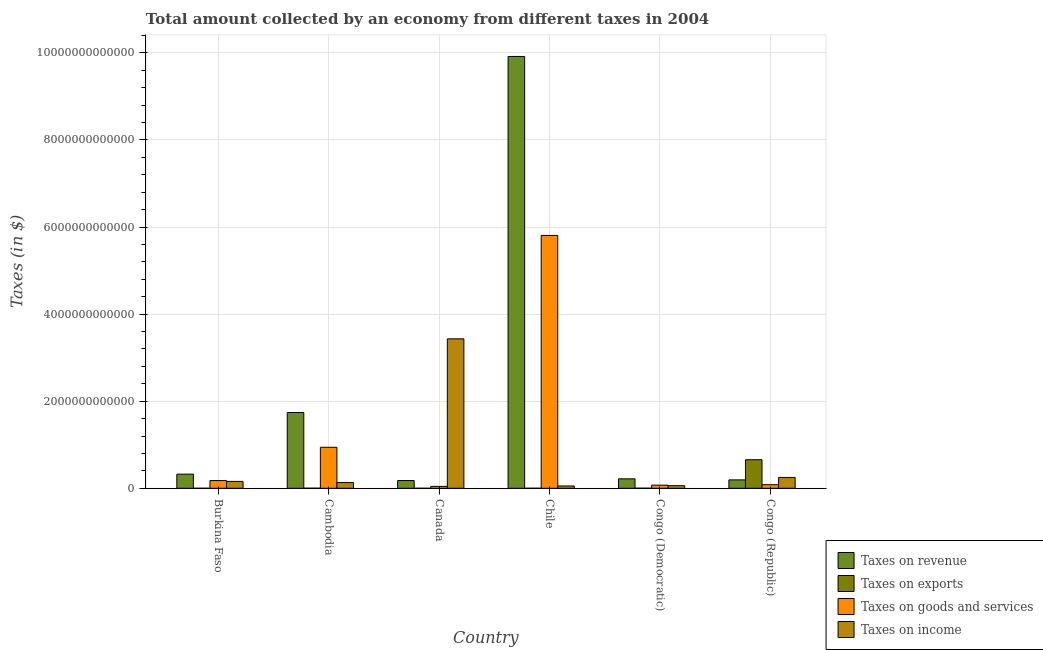How many groups of bars are there?
Your answer should be compact. 6. Are the number of bars on each tick of the X-axis equal?
Make the answer very short. Yes. How many bars are there on the 2nd tick from the left?
Make the answer very short. 4. What is the label of the 3rd group of bars from the left?
Your answer should be compact. Canada. What is the amount collected as tax on income in Chile?
Your answer should be very brief. 5.31e+1. Across all countries, what is the maximum amount collected as tax on income?
Make the answer very short. 3.43e+12. Across all countries, what is the minimum amount collected as tax on revenue?
Make the answer very short. 1.78e+11. In which country was the amount collected as tax on income minimum?
Ensure brevity in your answer.  Chile. What is the total amount collected as tax on exports in the graph?
Your answer should be very brief. 6.59e+11. What is the difference between the amount collected as tax on income in Chile and that in Congo (Democratic)?
Ensure brevity in your answer.  -6.23e+09. What is the difference between the amount collected as tax on exports in Cambodia and the amount collected as tax on goods in Burkina Faso?
Your response must be concise. -1.76e+11. What is the average amount collected as tax on exports per country?
Make the answer very short. 1.10e+11. What is the difference between the amount collected as tax on exports and amount collected as tax on revenue in Cambodia?
Give a very brief answer. -1.74e+12. In how many countries, is the amount collected as tax on goods greater than 1600000000000 $?
Keep it short and to the point. 1. What is the ratio of the amount collected as tax on goods in Canada to that in Congo (Republic)?
Provide a succinct answer. 0.53. Is the amount collected as tax on goods in Burkina Faso less than that in Canada?
Ensure brevity in your answer.  No. Is the difference between the amount collected as tax on revenue in Cambodia and Canada greater than the difference between the amount collected as tax on goods in Cambodia and Canada?
Ensure brevity in your answer.  Yes. What is the difference between the highest and the second highest amount collected as tax on revenue?
Provide a succinct answer. 8.18e+12. What is the difference between the highest and the lowest amount collected as tax on income?
Keep it short and to the point. 3.38e+12. Is the sum of the amount collected as tax on goods in Burkina Faso and Canada greater than the maximum amount collected as tax on exports across all countries?
Ensure brevity in your answer.  No. What does the 3rd bar from the left in Canada represents?
Your answer should be very brief. Taxes on goods and services. What does the 2nd bar from the right in Canada represents?
Your answer should be very brief. Taxes on goods and services. Is it the case that in every country, the sum of the amount collected as tax on revenue and amount collected as tax on exports is greater than the amount collected as tax on goods?
Your answer should be very brief. Yes. Are all the bars in the graph horizontal?
Offer a terse response. No. What is the difference between two consecutive major ticks on the Y-axis?
Give a very brief answer. 2.00e+12. Where does the legend appear in the graph?
Offer a terse response. Bottom right. How are the legend labels stacked?
Keep it short and to the point. Vertical. What is the title of the graph?
Make the answer very short. Total amount collected by an economy from different taxes in 2004. Does "Greece" appear as one of the legend labels in the graph?
Your answer should be compact. No. What is the label or title of the Y-axis?
Provide a succinct answer. Taxes (in $). What is the Taxes (in $) in Taxes on revenue in Burkina Faso?
Ensure brevity in your answer.  3.25e+11. What is the Taxes (in $) in Taxes on exports in Burkina Faso?
Make the answer very short. 1.08e+07. What is the Taxes (in $) in Taxes on goods and services in Burkina Faso?
Your answer should be compact. 1.77e+11. What is the Taxes (in $) in Taxes on income in Burkina Faso?
Provide a succinct answer. 1.58e+11. What is the Taxes (in $) of Taxes on revenue in Cambodia?
Offer a very short reply. 1.74e+12. What is the Taxes (in $) in Taxes on exports in Cambodia?
Your response must be concise. 1.60e+09. What is the Taxes (in $) of Taxes on goods and services in Cambodia?
Keep it short and to the point. 9.42e+11. What is the Taxes (in $) of Taxes on income in Cambodia?
Provide a succinct answer. 1.31e+11. What is the Taxes (in $) in Taxes on revenue in Canada?
Offer a terse response. 1.78e+11. What is the Taxes (in $) in Taxes on exports in Canada?
Ensure brevity in your answer.  4.41e+06. What is the Taxes (in $) in Taxes on goods and services in Canada?
Offer a terse response. 4.36e+1. What is the Taxes (in $) in Taxes on income in Canada?
Offer a terse response. 3.43e+12. What is the Taxes (in $) in Taxes on revenue in Chile?
Give a very brief answer. 9.92e+12. What is the Taxes (in $) of Taxes on exports in Chile?
Ensure brevity in your answer.  5.27e+08. What is the Taxes (in $) in Taxes on goods and services in Chile?
Offer a terse response. 5.81e+12. What is the Taxes (in $) of Taxes on income in Chile?
Give a very brief answer. 5.31e+1. What is the Taxes (in $) of Taxes on revenue in Congo (Democratic)?
Provide a succinct answer. 2.17e+11. What is the Taxes (in $) of Taxes on exports in Congo (Democratic)?
Your answer should be compact. 1.62e+09. What is the Taxes (in $) of Taxes on goods and services in Congo (Democratic)?
Ensure brevity in your answer.  7.21e+1. What is the Taxes (in $) in Taxes on income in Congo (Democratic)?
Your response must be concise. 5.93e+1. What is the Taxes (in $) in Taxes on revenue in Congo (Republic)?
Your answer should be very brief. 1.93e+11. What is the Taxes (in $) in Taxes on exports in Congo (Republic)?
Provide a succinct answer. 6.56e+11. What is the Taxes (in $) of Taxes on goods and services in Congo (Republic)?
Provide a short and direct response. 8.21e+1. What is the Taxes (in $) of Taxes on income in Congo (Republic)?
Keep it short and to the point. 2.49e+11. Across all countries, what is the maximum Taxes (in $) of Taxes on revenue?
Your answer should be compact. 9.92e+12. Across all countries, what is the maximum Taxes (in $) of Taxes on exports?
Provide a succinct answer. 6.56e+11. Across all countries, what is the maximum Taxes (in $) in Taxes on goods and services?
Give a very brief answer. 5.81e+12. Across all countries, what is the maximum Taxes (in $) of Taxes on income?
Make the answer very short. 3.43e+12. Across all countries, what is the minimum Taxes (in $) of Taxes on revenue?
Provide a succinct answer. 1.78e+11. Across all countries, what is the minimum Taxes (in $) in Taxes on exports?
Offer a terse response. 4.41e+06. Across all countries, what is the minimum Taxes (in $) of Taxes on goods and services?
Your answer should be compact. 4.36e+1. Across all countries, what is the minimum Taxes (in $) in Taxes on income?
Offer a very short reply. 5.31e+1. What is the total Taxes (in $) in Taxes on revenue in the graph?
Provide a succinct answer. 1.26e+13. What is the total Taxes (in $) in Taxes on exports in the graph?
Provide a succinct answer. 6.59e+11. What is the total Taxes (in $) of Taxes on goods and services in the graph?
Offer a very short reply. 7.12e+12. What is the total Taxes (in $) in Taxes on income in the graph?
Provide a succinct answer. 4.08e+12. What is the difference between the Taxes (in $) of Taxes on revenue in Burkina Faso and that in Cambodia?
Provide a short and direct response. -1.42e+12. What is the difference between the Taxes (in $) of Taxes on exports in Burkina Faso and that in Cambodia?
Your response must be concise. -1.59e+09. What is the difference between the Taxes (in $) of Taxes on goods and services in Burkina Faso and that in Cambodia?
Your response must be concise. -7.65e+11. What is the difference between the Taxes (in $) of Taxes on income in Burkina Faso and that in Cambodia?
Provide a short and direct response. 2.66e+1. What is the difference between the Taxes (in $) in Taxes on revenue in Burkina Faso and that in Canada?
Your response must be concise. 1.47e+11. What is the difference between the Taxes (in $) in Taxes on exports in Burkina Faso and that in Canada?
Keep it short and to the point. 6.44e+06. What is the difference between the Taxes (in $) in Taxes on goods and services in Burkina Faso and that in Canada?
Provide a short and direct response. 1.34e+11. What is the difference between the Taxes (in $) of Taxes on income in Burkina Faso and that in Canada?
Give a very brief answer. -3.27e+12. What is the difference between the Taxes (in $) in Taxes on revenue in Burkina Faso and that in Chile?
Offer a terse response. -9.59e+12. What is the difference between the Taxes (in $) in Taxes on exports in Burkina Faso and that in Chile?
Provide a succinct answer. -5.16e+08. What is the difference between the Taxes (in $) in Taxes on goods and services in Burkina Faso and that in Chile?
Your answer should be very brief. -5.63e+12. What is the difference between the Taxes (in $) in Taxes on income in Burkina Faso and that in Chile?
Your response must be concise. 1.05e+11. What is the difference between the Taxes (in $) of Taxes on revenue in Burkina Faso and that in Congo (Democratic)?
Ensure brevity in your answer.  1.08e+11. What is the difference between the Taxes (in $) of Taxes on exports in Burkina Faso and that in Congo (Democratic)?
Your answer should be compact. -1.60e+09. What is the difference between the Taxes (in $) in Taxes on goods and services in Burkina Faso and that in Congo (Democratic)?
Give a very brief answer. 1.05e+11. What is the difference between the Taxes (in $) in Taxes on income in Burkina Faso and that in Congo (Democratic)?
Give a very brief answer. 9.86e+1. What is the difference between the Taxes (in $) in Taxes on revenue in Burkina Faso and that in Congo (Republic)?
Provide a succinct answer. 1.32e+11. What is the difference between the Taxes (in $) in Taxes on exports in Burkina Faso and that in Congo (Republic)?
Your answer should be compact. -6.56e+11. What is the difference between the Taxes (in $) in Taxes on goods and services in Burkina Faso and that in Congo (Republic)?
Provide a short and direct response. 9.52e+1. What is the difference between the Taxes (in $) of Taxes on income in Burkina Faso and that in Congo (Republic)?
Keep it short and to the point. -9.11e+1. What is the difference between the Taxes (in $) in Taxes on revenue in Cambodia and that in Canada?
Give a very brief answer. 1.56e+12. What is the difference between the Taxes (in $) in Taxes on exports in Cambodia and that in Canada?
Offer a very short reply. 1.60e+09. What is the difference between the Taxes (in $) of Taxes on goods and services in Cambodia and that in Canada?
Give a very brief answer. 8.98e+11. What is the difference between the Taxes (in $) of Taxes on income in Cambodia and that in Canada?
Offer a very short reply. -3.30e+12. What is the difference between the Taxes (in $) of Taxes on revenue in Cambodia and that in Chile?
Provide a succinct answer. -8.18e+12. What is the difference between the Taxes (in $) in Taxes on exports in Cambodia and that in Chile?
Your answer should be very brief. 1.07e+09. What is the difference between the Taxes (in $) of Taxes on goods and services in Cambodia and that in Chile?
Offer a very short reply. -4.87e+12. What is the difference between the Taxes (in $) in Taxes on income in Cambodia and that in Chile?
Your response must be concise. 7.83e+1. What is the difference between the Taxes (in $) in Taxes on revenue in Cambodia and that in Congo (Democratic)?
Give a very brief answer. 1.52e+12. What is the difference between the Taxes (in $) in Taxes on exports in Cambodia and that in Congo (Democratic)?
Provide a succinct answer. -1.54e+07. What is the difference between the Taxes (in $) of Taxes on goods and services in Cambodia and that in Congo (Democratic)?
Your answer should be compact. 8.70e+11. What is the difference between the Taxes (in $) in Taxes on income in Cambodia and that in Congo (Democratic)?
Your response must be concise. 7.20e+1. What is the difference between the Taxes (in $) in Taxes on revenue in Cambodia and that in Congo (Republic)?
Your response must be concise. 1.55e+12. What is the difference between the Taxes (in $) of Taxes on exports in Cambodia and that in Congo (Republic)?
Offer a very short reply. -6.54e+11. What is the difference between the Taxes (in $) of Taxes on goods and services in Cambodia and that in Congo (Republic)?
Give a very brief answer. 8.60e+11. What is the difference between the Taxes (in $) in Taxes on income in Cambodia and that in Congo (Republic)?
Your answer should be very brief. -1.18e+11. What is the difference between the Taxes (in $) of Taxes on revenue in Canada and that in Chile?
Offer a terse response. -9.74e+12. What is the difference between the Taxes (in $) of Taxes on exports in Canada and that in Chile?
Make the answer very short. -5.23e+08. What is the difference between the Taxes (in $) of Taxes on goods and services in Canada and that in Chile?
Keep it short and to the point. -5.76e+12. What is the difference between the Taxes (in $) of Taxes on income in Canada and that in Chile?
Ensure brevity in your answer.  3.38e+12. What is the difference between the Taxes (in $) in Taxes on revenue in Canada and that in Congo (Democratic)?
Your answer should be very brief. -3.92e+1. What is the difference between the Taxes (in $) in Taxes on exports in Canada and that in Congo (Democratic)?
Keep it short and to the point. -1.61e+09. What is the difference between the Taxes (in $) of Taxes on goods and services in Canada and that in Congo (Democratic)?
Your answer should be compact. -2.85e+1. What is the difference between the Taxes (in $) in Taxes on income in Canada and that in Congo (Democratic)?
Your answer should be very brief. 3.37e+12. What is the difference between the Taxes (in $) of Taxes on revenue in Canada and that in Congo (Republic)?
Provide a short and direct response. -1.49e+1. What is the difference between the Taxes (in $) in Taxes on exports in Canada and that in Congo (Republic)?
Offer a terse response. -6.56e+11. What is the difference between the Taxes (in $) of Taxes on goods and services in Canada and that in Congo (Republic)?
Your answer should be very brief. -3.84e+1. What is the difference between the Taxes (in $) of Taxes on income in Canada and that in Congo (Republic)?
Your answer should be compact. 3.18e+12. What is the difference between the Taxes (in $) in Taxes on revenue in Chile and that in Congo (Democratic)?
Offer a terse response. 9.70e+12. What is the difference between the Taxes (in $) in Taxes on exports in Chile and that in Congo (Democratic)?
Provide a short and direct response. -1.09e+09. What is the difference between the Taxes (in $) of Taxes on goods and services in Chile and that in Congo (Democratic)?
Your response must be concise. 5.74e+12. What is the difference between the Taxes (in $) of Taxes on income in Chile and that in Congo (Democratic)?
Your answer should be very brief. -6.23e+09. What is the difference between the Taxes (in $) in Taxes on revenue in Chile and that in Congo (Republic)?
Your answer should be very brief. 9.73e+12. What is the difference between the Taxes (in $) of Taxes on exports in Chile and that in Congo (Republic)?
Your response must be concise. -6.55e+11. What is the difference between the Taxes (in $) in Taxes on goods and services in Chile and that in Congo (Republic)?
Keep it short and to the point. 5.73e+12. What is the difference between the Taxes (in $) of Taxes on income in Chile and that in Congo (Republic)?
Offer a terse response. -1.96e+11. What is the difference between the Taxes (in $) of Taxes on revenue in Congo (Democratic) and that in Congo (Republic)?
Provide a succinct answer. 2.43e+1. What is the difference between the Taxes (in $) of Taxes on exports in Congo (Democratic) and that in Congo (Republic)?
Your answer should be very brief. -6.54e+11. What is the difference between the Taxes (in $) in Taxes on goods and services in Congo (Democratic) and that in Congo (Republic)?
Make the answer very short. -9.97e+09. What is the difference between the Taxes (in $) in Taxes on income in Congo (Democratic) and that in Congo (Republic)?
Make the answer very short. -1.90e+11. What is the difference between the Taxes (in $) of Taxes on revenue in Burkina Faso and the Taxes (in $) of Taxes on exports in Cambodia?
Your response must be concise. 3.23e+11. What is the difference between the Taxes (in $) of Taxes on revenue in Burkina Faso and the Taxes (in $) of Taxes on goods and services in Cambodia?
Offer a terse response. -6.17e+11. What is the difference between the Taxes (in $) in Taxes on revenue in Burkina Faso and the Taxes (in $) in Taxes on income in Cambodia?
Offer a terse response. 1.93e+11. What is the difference between the Taxes (in $) of Taxes on exports in Burkina Faso and the Taxes (in $) of Taxes on goods and services in Cambodia?
Provide a succinct answer. -9.42e+11. What is the difference between the Taxes (in $) of Taxes on exports in Burkina Faso and the Taxes (in $) of Taxes on income in Cambodia?
Give a very brief answer. -1.31e+11. What is the difference between the Taxes (in $) in Taxes on goods and services in Burkina Faso and the Taxes (in $) in Taxes on income in Cambodia?
Make the answer very short. 4.59e+1. What is the difference between the Taxes (in $) in Taxes on revenue in Burkina Faso and the Taxes (in $) in Taxes on exports in Canada?
Offer a very short reply. 3.25e+11. What is the difference between the Taxes (in $) in Taxes on revenue in Burkina Faso and the Taxes (in $) in Taxes on goods and services in Canada?
Your answer should be compact. 2.81e+11. What is the difference between the Taxes (in $) in Taxes on revenue in Burkina Faso and the Taxes (in $) in Taxes on income in Canada?
Offer a very short reply. -3.11e+12. What is the difference between the Taxes (in $) of Taxes on exports in Burkina Faso and the Taxes (in $) of Taxes on goods and services in Canada?
Offer a terse response. -4.36e+1. What is the difference between the Taxes (in $) in Taxes on exports in Burkina Faso and the Taxes (in $) in Taxes on income in Canada?
Ensure brevity in your answer.  -3.43e+12. What is the difference between the Taxes (in $) in Taxes on goods and services in Burkina Faso and the Taxes (in $) in Taxes on income in Canada?
Give a very brief answer. -3.26e+12. What is the difference between the Taxes (in $) in Taxes on revenue in Burkina Faso and the Taxes (in $) in Taxes on exports in Chile?
Your response must be concise. 3.24e+11. What is the difference between the Taxes (in $) in Taxes on revenue in Burkina Faso and the Taxes (in $) in Taxes on goods and services in Chile?
Make the answer very short. -5.48e+12. What is the difference between the Taxes (in $) of Taxes on revenue in Burkina Faso and the Taxes (in $) of Taxes on income in Chile?
Your answer should be very brief. 2.72e+11. What is the difference between the Taxes (in $) in Taxes on exports in Burkina Faso and the Taxes (in $) in Taxes on goods and services in Chile?
Make the answer very short. -5.81e+12. What is the difference between the Taxes (in $) of Taxes on exports in Burkina Faso and the Taxes (in $) of Taxes on income in Chile?
Offer a very short reply. -5.31e+1. What is the difference between the Taxes (in $) in Taxes on goods and services in Burkina Faso and the Taxes (in $) in Taxes on income in Chile?
Offer a terse response. 1.24e+11. What is the difference between the Taxes (in $) in Taxes on revenue in Burkina Faso and the Taxes (in $) in Taxes on exports in Congo (Democratic)?
Ensure brevity in your answer.  3.23e+11. What is the difference between the Taxes (in $) of Taxes on revenue in Burkina Faso and the Taxes (in $) of Taxes on goods and services in Congo (Democratic)?
Offer a very short reply. 2.53e+11. What is the difference between the Taxes (in $) in Taxes on revenue in Burkina Faso and the Taxes (in $) in Taxes on income in Congo (Democratic)?
Keep it short and to the point. 2.65e+11. What is the difference between the Taxes (in $) of Taxes on exports in Burkina Faso and the Taxes (in $) of Taxes on goods and services in Congo (Democratic)?
Keep it short and to the point. -7.21e+1. What is the difference between the Taxes (in $) of Taxes on exports in Burkina Faso and the Taxes (in $) of Taxes on income in Congo (Democratic)?
Your answer should be very brief. -5.93e+1. What is the difference between the Taxes (in $) of Taxes on goods and services in Burkina Faso and the Taxes (in $) of Taxes on income in Congo (Democratic)?
Your answer should be very brief. 1.18e+11. What is the difference between the Taxes (in $) in Taxes on revenue in Burkina Faso and the Taxes (in $) in Taxes on exports in Congo (Republic)?
Your answer should be very brief. -3.31e+11. What is the difference between the Taxes (in $) of Taxes on revenue in Burkina Faso and the Taxes (in $) of Taxes on goods and services in Congo (Republic)?
Ensure brevity in your answer.  2.43e+11. What is the difference between the Taxes (in $) in Taxes on revenue in Burkina Faso and the Taxes (in $) in Taxes on income in Congo (Republic)?
Keep it short and to the point. 7.56e+1. What is the difference between the Taxes (in $) in Taxes on exports in Burkina Faso and the Taxes (in $) in Taxes on goods and services in Congo (Republic)?
Your answer should be compact. -8.21e+1. What is the difference between the Taxes (in $) in Taxes on exports in Burkina Faso and the Taxes (in $) in Taxes on income in Congo (Republic)?
Your answer should be very brief. -2.49e+11. What is the difference between the Taxes (in $) in Taxes on goods and services in Burkina Faso and the Taxes (in $) in Taxes on income in Congo (Republic)?
Offer a terse response. -7.17e+1. What is the difference between the Taxes (in $) of Taxes on revenue in Cambodia and the Taxes (in $) of Taxes on exports in Canada?
Give a very brief answer. 1.74e+12. What is the difference between the Taxes (in $) of Taxes on revenue in Cambodia and the Taxes (in $) of Taxes on goods and services in Canada?
Your response must be concise. 1.70e+12. What is the difference between the Taxes (in $) in Taxes on revenue in Cambodia and the Taxes (in $) in Taxes on income in Canada?
Provide a short and direct response. -1.69e+12. What is the difference between the Taxes (in $) in Taxes on exports in Cambodia and the Taxes (in $) in Taxes on goods and services in Canada?
Give a very brief answer. -4.20e+1. What is the difference between the Taxes (in $) of Taxes on exports in Cambodia and the Taxes (in $) of Taxes on income in Canada?
Provide a short and direct response. -3.43e+12. What is the difference between the Taxes (in $) of Taxes on goods and services in Cambodia and the Taxes (in $) of Taxes on income in Canada?
Give a very brief answer. -2.49e+12. What is the difference between the Taxes (in $) of Taxes on revenue in Cambodia and the Taxes (in $) of Taxes on exports in Chile?
Offer a very short reply. 1.74e+12. What is the difference between the Taxes (in $) of Taxes on revenue in Cambodia and the Taxes (in $) of Taxes on goods and services in Chile?
Ensure brevity in your answer.  -4.07e+12. What is the difference between the Taxes (in $) in Taxes on revenue in Cambodia and the Taxes (in $) in Taxes on income in Chile?
Provide a succinct answer. 1.69e+12. What is the difference between the Taxes (in $) of Taxes on exports in Cambodia and the Taxes (in $) of Taxes on goods and services in Chile?
Provide a succinct answer. -5.81e+12. What is the difference between the Taxes (in $) in Taxes on exports in Cambodia and the Taxes (in $) in Taxes on income in Chile?
Your answer should be compact. -5.15e+1. What is the difference between the Taxes (in $) of Taxes on goods and services in Cambodia and the Taxes (in $) of Taxes on income in Chile?
Offer a terse response. 8.89e+11. What is the difference between the Taxes (in $) of Taxes on revenue in Cambodia and the Taxes (in $) of Taxes on exports in Congo (Democratic)?
Your answer should be compact. 1.74e+12. What is the difference between the Taxes (in $) in Taxes on revenue in Cambodia and the Taxes (in $) in Taxes on goods and services in Congo (Democratic)?
Give a very brief answer. 1.67e+12. What is the difference between the Taxes (in $) in Taxes on revenue in Cambodia and the Taxes (in $) in Taxes on income in Congo (Democratic)?
Your answer should be very brief. 1.68e+12. What is the difference between the Taxes (in $) of Taxes on exports in Cambodia and the Taxes (in $) of Taxes on goods and services in Congo (Democratic)?
Keep it short and to the point. -7.05e+1. What is the difference between the Taxes (in $) in Taxes on exports in Cambodia and the Taxes (in $) in Taxes on income in Congo (Democratic)?
Your response must be concise. -5.77e+1. What is the difference between the Taxes (in $) of Taxes on goods and services in Cambodia and the Taxes (in $) of Taxes on income in Congo (Democratic)?
Provide a succinct answer. 8.82e+11. What is the difference between the Taxes (in $) of Taxes on revenue in Cambodia and the Taxes (in $) of Taxes on exports in Congo (Republic)?
Offer a very short reply. 1.08e+12. What is the difference between the Taxes (in $) in Taxes on revenue in Cambodia and the Taxes (in $) in Taxes on goods and services in Congo (Republic)?
Keep it short and to the point. 1.66e+12. What is the difference between the Taxes (in $) of Taxes on revenue in Cambodia and the Taxes (in $) of Taxes on income in Congo (Republic)?
Your response must be concise. 1.49e+12. What is the difference between the Taxes (in $) of Taxes on exports in Cambodia and the Taxes (in $) of Taxes on goods and services in Congo (Republic)?
Ensure brevity in your answer.  -8.05e+1. What is the difference between the Taxes (in $) of Taxes on exports in Cambodia and the Taxes (in $) of Taxes on income in Congo (Republic)?
Your answer should be compact. -2.47e+11. What is the difference between the Taxes (in $) of Taxes on goods and services in Cambodia and the Taxes (in $) of Taxes on income in Congo (Republic)?
Ensure brevity in your answer.  6.93e+11. What is the difference between the Taxes (in $) in Taxes on revenue in Canada and the Taxes (in $) in Taxes on exports in Chile?
Offer a very short reply. 1.77e+11. What is the difference between the Taxes (in $) of Taxes on revenue in Canada and the Taxes (in $) of Taxes on goods and services in Chile?
Make the answer very short. -5.63e+12. What is the difference between the Taxes (in $) in Taxes on revenue in Canada and the Taxes (in $) in Taxes on income in Chile?
Your response must be concise. 1.25e+11. What is the difference between the Taxes (in $) of Taxes on exports in Canada and the Taxes (in $) of Taxes on goods and services in Chile?
Give a very brief answer. -5.81e+12. What is the difference between the Taxes (in $) of Taxes on exports in Canada and the Taxes (in $) of Taxes on income in Chile?
Ensure brevity in your answer.  -5.31e+1. What is the difference between the Taxes (in $) of Taxes on goods and services in Canada and the Taxes (in $) of Taxes on income in Chile?
Provide a succinct answer. -9.45e+09. What is the difference between the Taxes (in $) in Taxes on revenue in Canada and the Taxes (in $) in Taxes on exports in Congo (Democratic)?
Give a very brief answer. 1.76e+11. What is the difference between the Taxes (in $) in Taxes on revenue in Canada and the Taxes (in $) in Taxes on goods and services in Congo (Democratic)?
Your answer should be compact. 1.06e+11. What is the difference between the Taxes (in $) in Taxes on revenue in Canada and the Taxes (in $) in Taxes on income in Congo (Democratic)?
Keep it short and to the point. 1.19e+11. What is the difference between the Taxes (in $) in Taxes on exports in Canada and the Taxes (in $) in Taxes on goods and services in Congo (Democratic)?
Your answer should be compact. -7.21e+1. What is the difference between the Taxes (in $) of Taxes on exports in Canada and the Taxes (in $) of Taxes on income in Congo (Democratic)?
Provide a succinct answer. -5.93e+1. What is the difference between the Taxes (in $) of Taxes on goods and services in Canada and the Taxes (in $) of Taxes on income in Congo (Democratic)?
Ensure brevity in your answer.  -1.57e+1. What is the difference between the Taxes (in $) in Taxes on revenue in Canada and the Taxes (in $) in Taxes on exports in Congo (Republic)?
Your answer should be compact. -4.78e+11. What is the difference between the Taxes (in $) of Taxes on revenue in Canada and the Taxes (in $) of Taxes on goods and services in Congo (Republic)?
Ensure brevity in your answer.  9.58e+1. What is the difference between the Taxes (in $) in Taxes on revenue in Canada and the Taxes (in $) in Taxes on income in Congo (Republic)?
Provide a short and direct response. -7.11e+1. What is the difference between the Taxes (in $) in Taxes on exports in Canada and the Taxes (in $) in Taxes on goods and services in Congo (Republic)?
Give a very brief answer. -8.21e+1. What is the difference between the Taxes (in $) in Taxes on exports in Canada and the Taxes (in $) in Taxes on income in Congo (Republic)?
Offer a very short reply. -2.49e+11. What is the difference between the Taxes (in $) of Taxes on goods and services in Canada and the Taxes (in $) of Taxes on income in Congo (Republic)?
Offer a terse response. -2.05e+11. What is the difference between the Taxes (in $) in Taxes on revenue in Chile and the Taxes (in $) in Taxes on exports in Congo (Democratic)?
Provide a short and direct response. 9.92e+12. What is the difference between the Taxes (in $) of Taxes on revenue in Chile and the Taxes (in $) of Taxes on goods and services in Congo (Democratic)?
Your answer should be very brief. 9.85e+12. What is the difference between the Taxes (in $) of Taxes on revenue in Chile and the Taxes (in $) of Taxes on income in Congo (Democratic)?
Provide a succinct answer. 9.86e+12. What is the difference between the Taxes (in $) of Taxes on exports in Chile and the Taxes (in $) of Taxes on goods and services in Congo (Democratic)?
Ensure brevity in your answer.  -7.16e+1. What is the difference between the Taxes (in $) in Taxes on exports in Chile and the Taxes (in $) in Taxes on income in Congo (Democratic)?
Ensure brevity in your answer.  -5.88e+1. What is the difference between the Taxes (in $) in Taxes on goods and services in Chile and the Taxes (in $) in Taxes on income in Congo (Democratic)?
Keep it short and to the point. 5.75e+12. What is the difference between the Taxes (in $) in Taxes on revenue in Chile and the Taxes (in $) in Taxes on exports in Congo (Republic)?
Your response must be concise. 9.26e+12. What is the difference between the Taxes (in $) in Taxes on revenue in Chile and the Taxes (in $) in Taxes on goods and services in Congo (Republic)?
Your answer should be very brief. 9.84e+12. What is the difference between the Taxes (in $) of Taxes on revenue in Chile and the Taxes (in $) of Taxes on income in Congo (Republic)?
Provide a short and direct response. 9.67e+12. What is the difference between the Taxes (in $) in Taxes on exports in Chile and the Taxes (in $) in Taxes on goods and services in Congo (Republic)?
Your answer should be compact. -8.15e+1. What is the difference between the Taxes (in $) of Taxes on exports in Chile and the Taxes (in $) of Taxes on income in Congo (Republic)?
Your response must be concise. -2.48e+11. What is the difference between the Taxes (in $) of Taxes on goods and services in Chile and the Taxes (in $) of Taxes on income in Congo (Republic)?
Offer a terse response. 5.56e+12. What is the difference between the Taxes (in $) in Taxes on revenue in Congo (Democratic) and the Taxes (in $) in Taxes on exports in Congo (Republic)?
Provide a short and direct response. -4.39e+11. What is the difference between the Taxes (in $) of Taxes on revenue in Congo (Democratic) and the Taxes (in $) of Taxes on goods and services in Congo (Republic)?
Provide a succinct answer. 1.35e+11. What is the difference between the Taxes (in $) of Taxes on revenue in Congo (Democratic) and the Taxes (in $) of Taxes on income in Congo (Republic)?
Provide a succinct answer. -3.19e+1. What is the difference between the Taxes (in $) of Taxes on exports in Congo (Democratic) and the Taxes (in $) of Taxes on goods and services in Congo (Republic)?
Offer a terse response. -8.05e+1. What is the difference between the Taxes (in $) in Taxes on exports in Congo (Democratic) and the Taxes (in $) in Taxes on income in Congo (Republic)?
Provide a short and direct response. -2.47e+11. What is the difference between the Taxes (in $) of Taxes on goods and services in Congo (Democratic) and the Taxes (in $) of Taxes on income in Congo (Republic)?
Give a very brief answer. -1.77e+11. What is the average Taxes (in $) of Taxes on revenue per country?
Offer a very short reply. 2.10e+12. What is the average Taxes (in $) in Taxes on exports per country?
Provide a succinct answer. 1.10e+11. What is the average Taxes (in $) in Taxes on goods and services per country?
Your answer should be very brief. 1.19e+12. What is the average Taxes (in $) in Taxes on income per country?
Your answer should be compact. 6.81e+11. What is the difference between the Taxes (in $) in Taxes on revenue and Taxes (in $) in Taxes on exports in Burkina Faso?
Keep it short and to the point. 3.25e+11. What is the difference between the Taxes (in $) of Taxes on revenue and Taxes (in $) of Taxes on goods and services in Burkina Faso?
Your answer should be compact. 1.47e+11. What is the difference between the Taxes (in $) of Taxes on revenue and Taxes (in $) of Taxes on income in Burkina Faso?
Your response must be concise. 1.67e+11. What is the difference between the Taxes (in $) in Taxes on exports and Taxes (in $) in Taxes on goods and services in Burkina Faso?
Provide a short and direct response. -1.77e+11. What is the difference between the Taxes (in $) of Taxes on exports and Taxes (in $) of Taxes on income in Burkina Faso?
Give a very brief answer. -1.58e+11. What is the difference between the Taxes (in $) of Taxes on goods and services and Taxes (in $) of Taxes on income in Burkina Faso?
Give a very brief answer. 1.93e+1. What is the difference between the Taxes (in $) of Taxes on revenue and Taxes (in $) of Taxes on exports in Cambodia?
Provide a succinct answer. 1.74e+12. What is the difference between the Taxes (in $) of Taxes on revenue and Taxes (in $) of Taxes on goods and services in Cambodia?
Give a very brief answer. 7.98e+11. What is the difference between the Taxes (in $) of Taxes on revenue and Taxes (in $) of Taxes on income in Cambodia?
Make the answer very short. 1.61e+12. What is the difference between the Taxes (in $) in Taxes on exports and Taxes (in $) in Taxes on goods and services in Cambodia?
Offer a very short reply. -9.40e+11. What is the difference between the Taxes (in $) in Taxes on exports and Taxes (in $) in Taxes on income in Cambodia?
Offer a very short reply. -1.30e+11. What is the difference between the Taxes (in $) in Taxes on goods and services and Taxes (in $) in Taxes on income in Cambodia?
Ensure brevity in your answer.  8.10e+11. What is the difference between the Taxes (in $) in Taxes on revenue and Taxes (in $) in Taxes on exports in Canada?
Your answer should be compact. 1.78e+11. What is the difference between the Taxes (in $) in Taxes on revenue and Taxes (in $) in Taxes on goods and services in Canada?
Keep it short and to the point. 1.34e+11. What is the difference between the Taxes (in $) in Taxes on revenue and Taxes (in $) in Taxes on income in Canada?
Provide a short and direct response. -3.25e+12. What is the difference between the Taxes (in $) of Taxes on exports and Taxes (in $) of Taxes on goods and services in Canada?
Your response must be concise. -4.36e+1. What is the difference between the Taxes (in $) of Taxes on exports and Taxes (in $) of Taxes on income in Canada?
Provide a succinct answer. -3.43e+12. What is the difference between the Taxes (in $) in Taxes on goods and services and Taxes (in $) in Taxes on income in Canada?
Your response must be concise. -3.39e+12. What is the difference between the Taxes (in $) in Taxes on revenue and Taxes (in $) in Taxes on exports in Chile?
Your response must be concise. 9.92e+12. What is the difference between the Taxes (in $) of Taxes on revenue and Taxes (in $) of Taxes on goods and services in Chile?
Ensure brevity in your answer.  4.11e+12. What is the difference between the Taxes (in $) of Taxes on revenue and Taxes (in $) of Taxes on income in Chile?
Offer a very short reply. 9.87e+12. What is the difference between the Taxes (in $) in Taxes on exports and Taxes (in $) in Taxes on goods and services in Chile?
Give a very brief answer. -5.81e+12. What is the difference between the Taxes (in $) of Taxes on exports and Taxes (in $) of Taxes on income in Chile?
Your response must be concise. -5.25e+1. What is the difference between the Taxes (in $) of Taxes on goods and services and Taxes (in $) of Taxes on income in Chile?
Your response must be concise. 5.75e+12. What is the difference between the Taxes (in $) of Taxes on revenue and Taxes (in $) of Taxes on exports in Congo (Democratic)?
Your response must be concise. 2.15e+11. What is the difference between the Taxes (in $) in Taxes on revenue and Taxes (in $) in Taxes on goods and services in Congo (Democratic)?
Your answer should be very brief. 1.45e+11. What is the difference between the Taxes (in $) in Taxes on revenue and Taxes (in $) in Taxes on income in Congo (Democratic)?
Your answer should be very brief. 1.58e+11. What is the difference between the Taxes (in $) in Taxes on exports and Taxes (in $) in Taxes on goods and services in Congo (Democratic)?
Your response must be concise. -7.05e+1. What is the difference between the Taxes (in $) of Taxes on exports and Taxes (in $) of Taxes on income in Congo (Democratic)?
Give a very brief answer. -5.77e+1. What is the difference between the Taxes (in $) in Taxes on goods and services and Taxes (in $) in Taxes on income in Congo (Democratic)?
Your answer should be compact. 1.28e+1. What is the difference between the Taxes (in $) in Taxes on revenue and Taxes (in $) in Taxes on exports in Congo (Republic)?
Your answer should be compact. -4.63e+11. What is the difference between the Taxes (in $) of Taxes on revenue and Taxes (in $) of Taxes on goods and services in Congo (Republic)?
Your answer should be very brief. 1.11e+11. What is the difference between the Taxes (in $) of Taxes on revenue and Taxes (in $) of Taxes on income in Congo (Republic)?
Your answer should be very brief. -5.62e+1. What is the difference between the Taxes (in $) in Taxes on exports and Taxes (in $) in Taxes on goods and services in Congo (Republic)?
Offer a terse response. 5.74e+11. What is the difference between the Taxes (in $) of Taxes on exports and Taxes (in $) of Taxes on income in Congo (Republic)?
Provide a short and direct response. 4.07e+11. What is the difference between the Taxes (in $) of Taxes on goods and services and Taxes (in $) of Taxes on income in Congo (Republic)?
Offer a terse response. -1.67e+11. What is the ratio of the Taxes (in $) in Taxes on revenue in Burkina Faso to that in Cambodia?
Offer a very short reply. 0.19. What is the ratio of the Taxes (in $) of Taxes on exports in Burkina Faso to that in Cambodia?
Give a very brief answer. 0.01. What is the ratio of the Taxes (in $) in Taxes on goods and services in Burkina Faso to that in Cambodia?
Offer a terse response. 0.19. What is the ratio of the Taxes (in $) in Taxes on income in Burkina Faso to that in Cambodia?
Offer a very short reply. 1.2. What is the ratio of the Taxes (in $) in Taxes on revenue in Burkina Faso to that in Canada?
Your response must be concise. 1.82. What is the ratio of the Taxes (in $) of Taxes on exports in Burkina Faso to that in Canada?
Your answer should be compact. 2.46. What is the ratio of the Taxes (in $) of Taxes on goods and services in Burkina Faso to that in Canada?
Offer a terse response. 4.06. What is the ratio of the Taxes (in $) of Taxes on income in Burkina Faso to that in Canada?
Offer a very short reply. 0.05. What is the ratio of the Taxes (in $) of Taxes on revenue in Burkina Faso to that in Chile?
Offer a very short reply. 0.03. What is the ratio of the Taxes (in $) of Taxes on exports in Burkina Faso to that in Chile?
Your response must be concise. 0.02. What is the ratio of the Taxes (in $) of Taxes on goods and services in Burkina Faso to that in Chile?
Ensure brevity in your answer.  0.03. What is the ratio of the Taxes (in $) of Taxes on income in Burkina Faso to that in Chile?
Ensure brevity in your answer.  2.98. What is the ratio of the Taxes (in $) of Taxes on revenue in Burkina Faso to that in Congo (Democratic)?
Offer a very short reply. 1.5. What is the ratio of the Taxes (in $) of Taxes on exports in Burkina Faso to that in Congo (Democratic)?
Your response must be concise. 0.01. What is the ratio of the Taxes (in $) of Taxes on goods and services in Burkina Faso to that in Congo (Democratic)?
Make the answer very short. 2.46. What is the ratio of the Taxes (in $) in Taxes on income in Burkina Faso to that in Congo (Democratic)?
Your answer should be very brief. 2.66. What is the ratio of the Taxes (in $) of Taxes on revenue in Burkina Faso to that in Congo (Republic)?
Offer a terse response. 1.68. What is the ratio of the Taxes (in $) of Taxes on exports in Burkina Faso to that in Congo (Republic)?
Ensure brevity in your answer.  0. What is the ratio of the Taxes (in $) in Taxes on goods and services in Burkina Faso to that in Congo (Republic)?
Your answer should be compact. 2.16. What is the ratio of the Taxes (in $) of Taxes on income in Burkina Faso to that in Congo (Republic)?
Make the answer very short. 0.63. What is the ratio of the Taxes (in $) of Taxes on revenue in Cambodia to that in Canada?
Your answer should be very brief. 9.78. What is the ratio of the Taxes (in $) in Taxes on exports in Cambodia to that in Canada?
Your answer should be compact. 362.71. What is the ratio of the Taxes (in $) in Taxes on goods and services in Cambodia to that in Canada?
Make the answer very short. 21.59. What is the ratio of the Taxes (in $) of Taxes on income in Cambodia to that in Canada?
Your answer should be compact. 0.04. What is the ratio of the Taxes (in $) of Taxes on revenue in Cambodia to that in Chile?
Keep it short and to the point. 0.18. What is the ratio of the Taxes (in $) in Taxes on exports in Cambodia to that in Chile?
Your answer should be compact. 3.04. What is the ratio of the Taxes (in $) of Taxes on goods and services in Cambodia to that in Chile?
Give a very brief answer. 0.16. What is the ratio of the Taxes (in $) of Taxes on income in Cambodia to that in Chile?
Keep it short and to the point. 2.47. What is the ratio of the Taxes (in $) of Taxes on revenue in Cambodia to that in Congo (Democratic)?
Offer a terse response. 8.02. What is the ratio of the Taxes (in $) of Taxes on goods and services in Cambodia to that in Congo (Democratic)?
Keep it short and to the point. 13.06. What is the ratio of the Taxes (in $) of Taxes on income in Cambodia to that in Congo (Democratic)?
Give a very brief answer. 2.21. What is the ratio of the Taxes (in $) in Taxes on revenue in Cambodia to that in Congo (Republic)?
Offer a very short reply. 9.03. What is the ratio of the Taxes (in $) of Taxes on exports in Cambodia to that in Congo (Republic)?
Your response must be concise. 0. What is the ratio of the Taxes (in $) of Taxes on goods and services in Cambodia to that in Congo (Republic)?
Your response must be concise. 11.48. What is the ratio of the Taxes (in $) of Taxes on income in Cambodia to that in Congo (Republic)?
Offer a very short reply. 0.53. What is the ratio of the Taxes (in $) in Taxes on revenue in Canada to that in Chile?
Offer a very short reply. 0.02. What is the ratio of the Taxes (in $) in Taxes on exports in Canada to that in Chile?
Your response must be concise. 0.01. What is the ratio of the Taxes (in $) in Taxes on goods and services in Canada to that in Chile?
Ensure brevity in your answer.  0.01. What is the ratio of the Taxes (in $) of Taxes on income in Canada to that in Chile?
Give a very brief answer. 64.68. What is the ratio of the Taxes (in $) in Taxes on revenue in Canada to that in Congo (Democratic)?
Your response must be concise. 0.82. What is the ratio of the Taxes (in $) in Taxes on exports in Canada to that in Congo (Democratic)?
Give a very brief answer. 0. What is the ratio of the Taxes (in $) in Taxes on goods and services in Canada to that in Congo (Democratic)?
Ensure brevity in your answer.  0.61. What is the ratio of the Taxes (in $) of Taxes on income in Canada to that in Congo (Democratic)?
Keep it short and to the point. 57.88. What is the ratio of the Taxes (in $) of Taxes on revenue in Canada to that in Congo (Republic)?
Your answer should be compact. 0.92. What is the ratio of the Taxes (in $) of Taxes on exports in Canada to that in Congo (Republic)?
Provide a succinct answer. 0. What is the ratio of the Taxes (in $) of Taxes on goods and services in Canada to that in Congo (Republic)?
Ensure brevity in your answer.  0.53. What is the ratio of the Taxes (in $) in Taxes on income in Canada to that in Congo (Republic)?
Provide a succinct answer. 13.79. What is the ratio of the Taxes (in $) in Taxes on revenue in Chile to that in Congo (Democratic)?
Provide a succinct answer. 45.69. What is the ratio of the Taxes (in $) in Taxes on exports in Chile to that in Congo (Democratic)?
Your answer should be very brief. 0.33. What is the ratio of the Taxes (in $) of Taxes on goods and services in Chile to that in Congo (Democratic)?
Your response must be concise. 80.55. What is the ratio of the Taxes (in $) of Taxes on income in Chile to that in Congo (Democratic)?
Your response must be concise. 0.9. What is the ratio of the Taxes (in $) in Taxes on revenue in Chile to that in Congo (Republic)?
Offer a very short reply. 51.46. What is the ratio of the Taxes (in $) in Taxes on exports in Chile to that in Congo (Republic)?
Offer a very short reply. 0. What is the ratio of the Taxes (in $) in Taxes on goods and services in Chile to that in Congo (Republic)?
Your answer should be very brief. 70.77. What is the ratio of the Taxes (in $) in Taxes on income in Chile to that in Congo (Republic)?
Keep it short and to the point. 0.21. What is the ratio of the Taxes (in $) of Taxes on revenue in Congo (Democratic) to that in Congo (Republic)?
Your response must be concise. 1.13. What is the ratio of the Taxes (in $) in Taxes on exports in Congo (Democratic) to that in Congo (Republic)?
Offer a terse response. 0. What is the ratio of the Taxes (in $) in Taxes on goods and services in Congo (Democratic) to that in Congo (Republic)?
Provide a short and direct response. 0.88. What is the ratio of the Taxes (in $) of Taxes on income in Congo (Democratic) to that in Congo (Republic)?
Ensure brevity in your answer.  0.24. What is the difference between the highest and the second highest Taxes (in $) of Taxes on revenue?
Ensure brevity in your answer.  8.18e+12. What is the difference between the highest and the second highest Taxes (in $) in Taxes on exports?
Ensure brevity in your answer.  6.54e+11. What is the difference between the highest and the second highest Taxes (in $) in Taxes on goods and services?
Keep it short and to the point. 4.87e+12. What is the difference between the highest and the second highest Taxes (in $) in Taxes on income?
Offer a terse response. 3.18e+12. What is the difference between the highest and the lowest Taxes (in $) of Taxes on revenue?
Offer a very short reply. 9.74e+12. What is the difference between the highest and the lowest Taxes (in $) of Taxes on exports?
Make the answer very short. 6.56e+11. What is the difference between the highest and the lowest Taxes (in $) of Taxes on goods and services?
Provide a short and direct response. 5.76e+12. What is the difference between the highest and the lowest Taxes (in $) of Taxes on income?
Make the answer very short. 3.38e+12. 